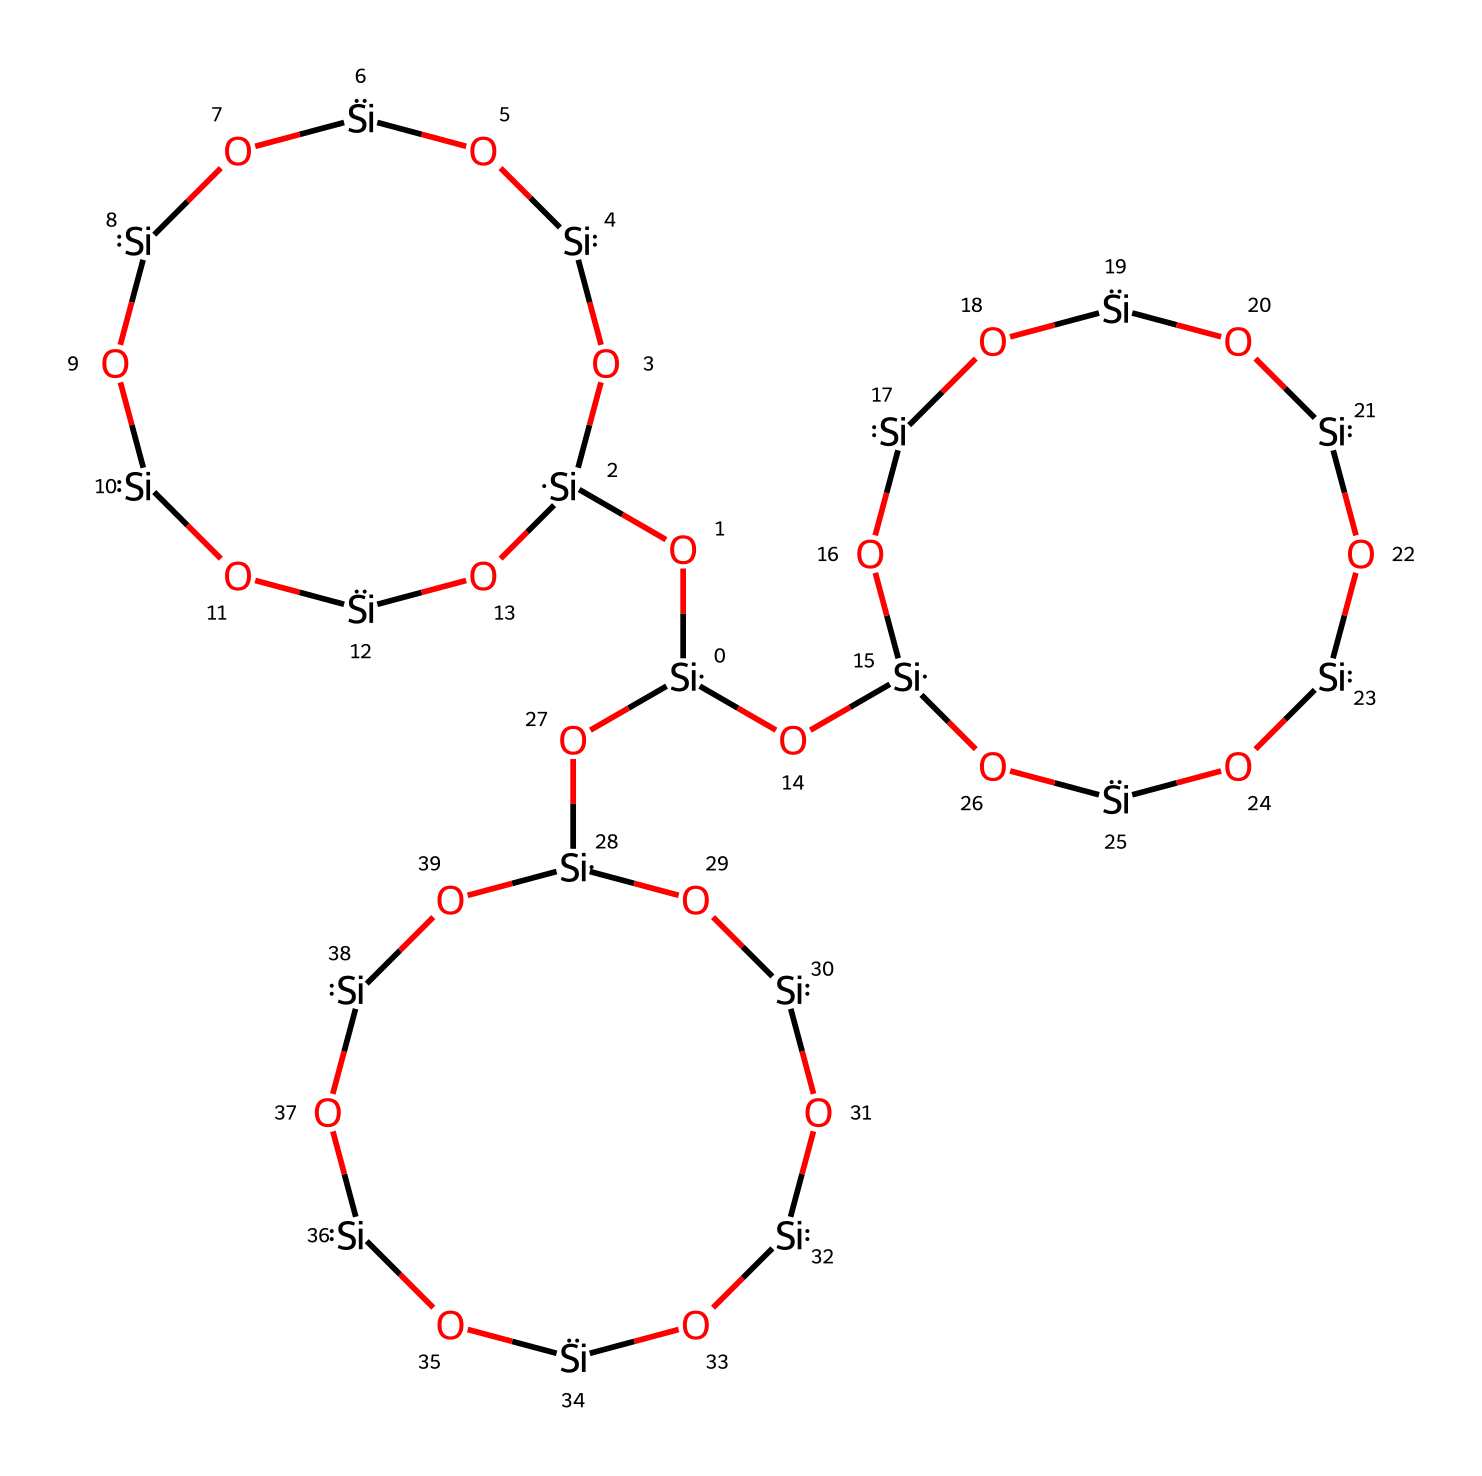What is the total number of silicon atoms in this cage compound? By analyzing the SMILES representation, it can be seen that there are several instances of the "Si" segment. Counting them brings us to a total of 6 silicon atoms.
Answer: six How many oxygen atoms are present in the structure? In the SMILES, we can identify the presence of the letter "O," which represents oxygen. By carefully counting them, there are 18 oxygen atoms included in the structure.
Answer: eighteen What type of chemical structure is represented by this compound? This chemical structure represents a silsesquioxane, which is characterized by a cage-like configuration of silicate units and their connectivity through oxygen atoms.
Answer: silsesquioxane What feature of this chemical structure contributes to its weather resistance? The cage structure with silicon-oxygen bonds creates a highly cross-linked network, which enhances durability and resistance to weathering effects.
Answer: cross-linked network How does the number of silicon atoms affect the properties of this silsesquioxane? An increased number of silicon atoms typically leads to a more extensive cross-linked network, improving mechanical strength, durability, and weather resistance in paint formulations.
Answer: improved strength What is the impact of the Si-O bond in this compound on its thermal stability? The Si-O bond in silsesquioxanes is strong, contributing to high thermal stability, which is crucial for exterior applications where temperature fluctuations can occur.
Answer: high thermal stability What makes this structure suitable for exterior paints? The structural integrity provided by the silsesquioxanes allows for resistance against harsh weather conditions, moisture, and UV degradation, making it particularly suitable for protective paints.
Answer: resistance to weather conditions 